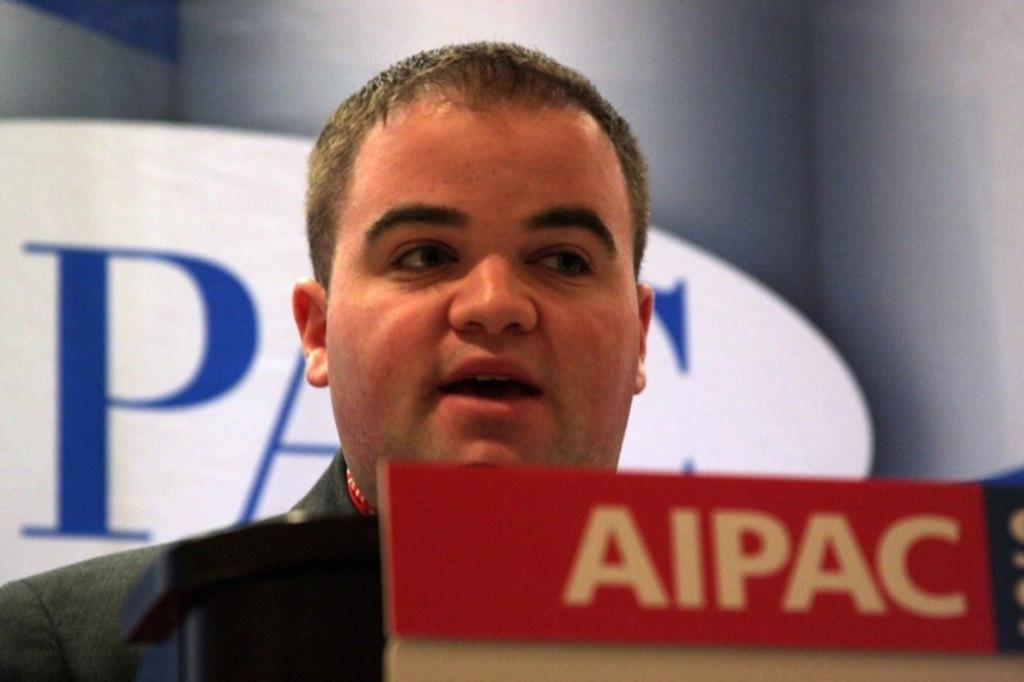Who is the main subject in the image? There is a man in the center of the image. What is the man standing in front of? There is a podium in front of the man. What can be seen in the background of the image? There is a board in the background of the image. What type of scent can be smelled coming from the shop in the image? There is no shop present in the image, so it is not possible to determine what scent might be smelled. 